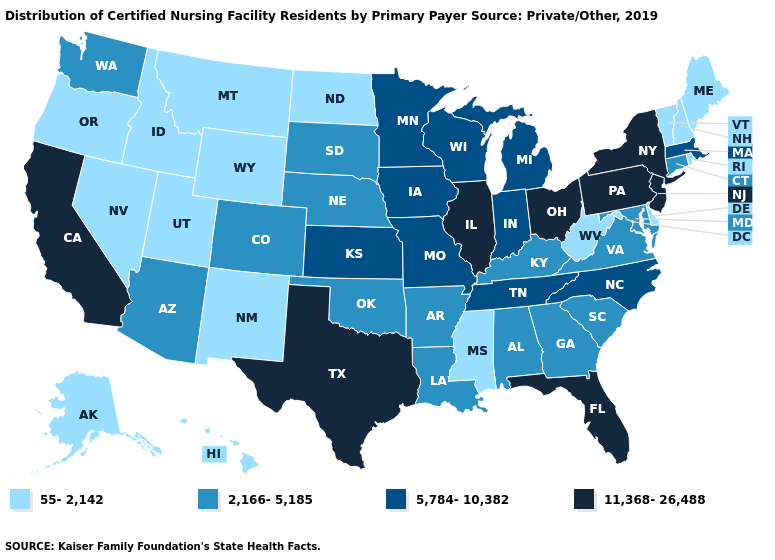Does the first symbol in the legend represent the smallest category?
Write a very short answer. Yes. Does the map have missing data?
Answer briefly. No. Which states have the highest value in the USA?
Write a very short answer. California, Florida, Illinois, New Jersey, New York, Ohio, Pennsylvania, Texas. Does Maine have the highest value in the Northeast?
Answer briefly. No. Does California have the lowest value in the USA?
Keep it brief. No. What is the value of Nevada?
Give a very brief answer. 55-2,142. What is the value of Nevada?
Give a very brief answer. 55-2,142. Does the first symbol in the legend represent the smallest category?
Keep it brief. Yes. Which states hav the highest value in the Northeast?
Answer briefly. New Jersey, New York, Pennsylvania. Which states have the highest value in the USA?
Keep it brief. California, Florida, Illinois, New Jersey, New York, Ohio, Pennsylvania, Texas. Which states have the lowest value in the USA?
Keep it brief. Alaska, Delaware, Hawaii, Idaho, Maine, Mississippi, Montana, Nevada, New Hampshire, New Mexico, North Dakota, Oregon, Rhode Island, Utah, Vermont, West Virginia, Wyoming. Name the states that have a value in the range 55-2,142?
Write a very short answer. Alaska, Delaware, Hawaii, Idaho, Maine, Mississippi, Montana, Nevada, New Hampshire, New Mexico, North Dakota, Oregon, Rhode Island, Utah, Vermont, West Virginia, Wyoming. Which states hav the highest value in the West?
Be succinct. California. What is the value of Wisconsin?
Short answer required. 5,784-10,382. What is the lowest value in states that border Rhode Island?
Give a very brief answer. 2,166-5,185. 